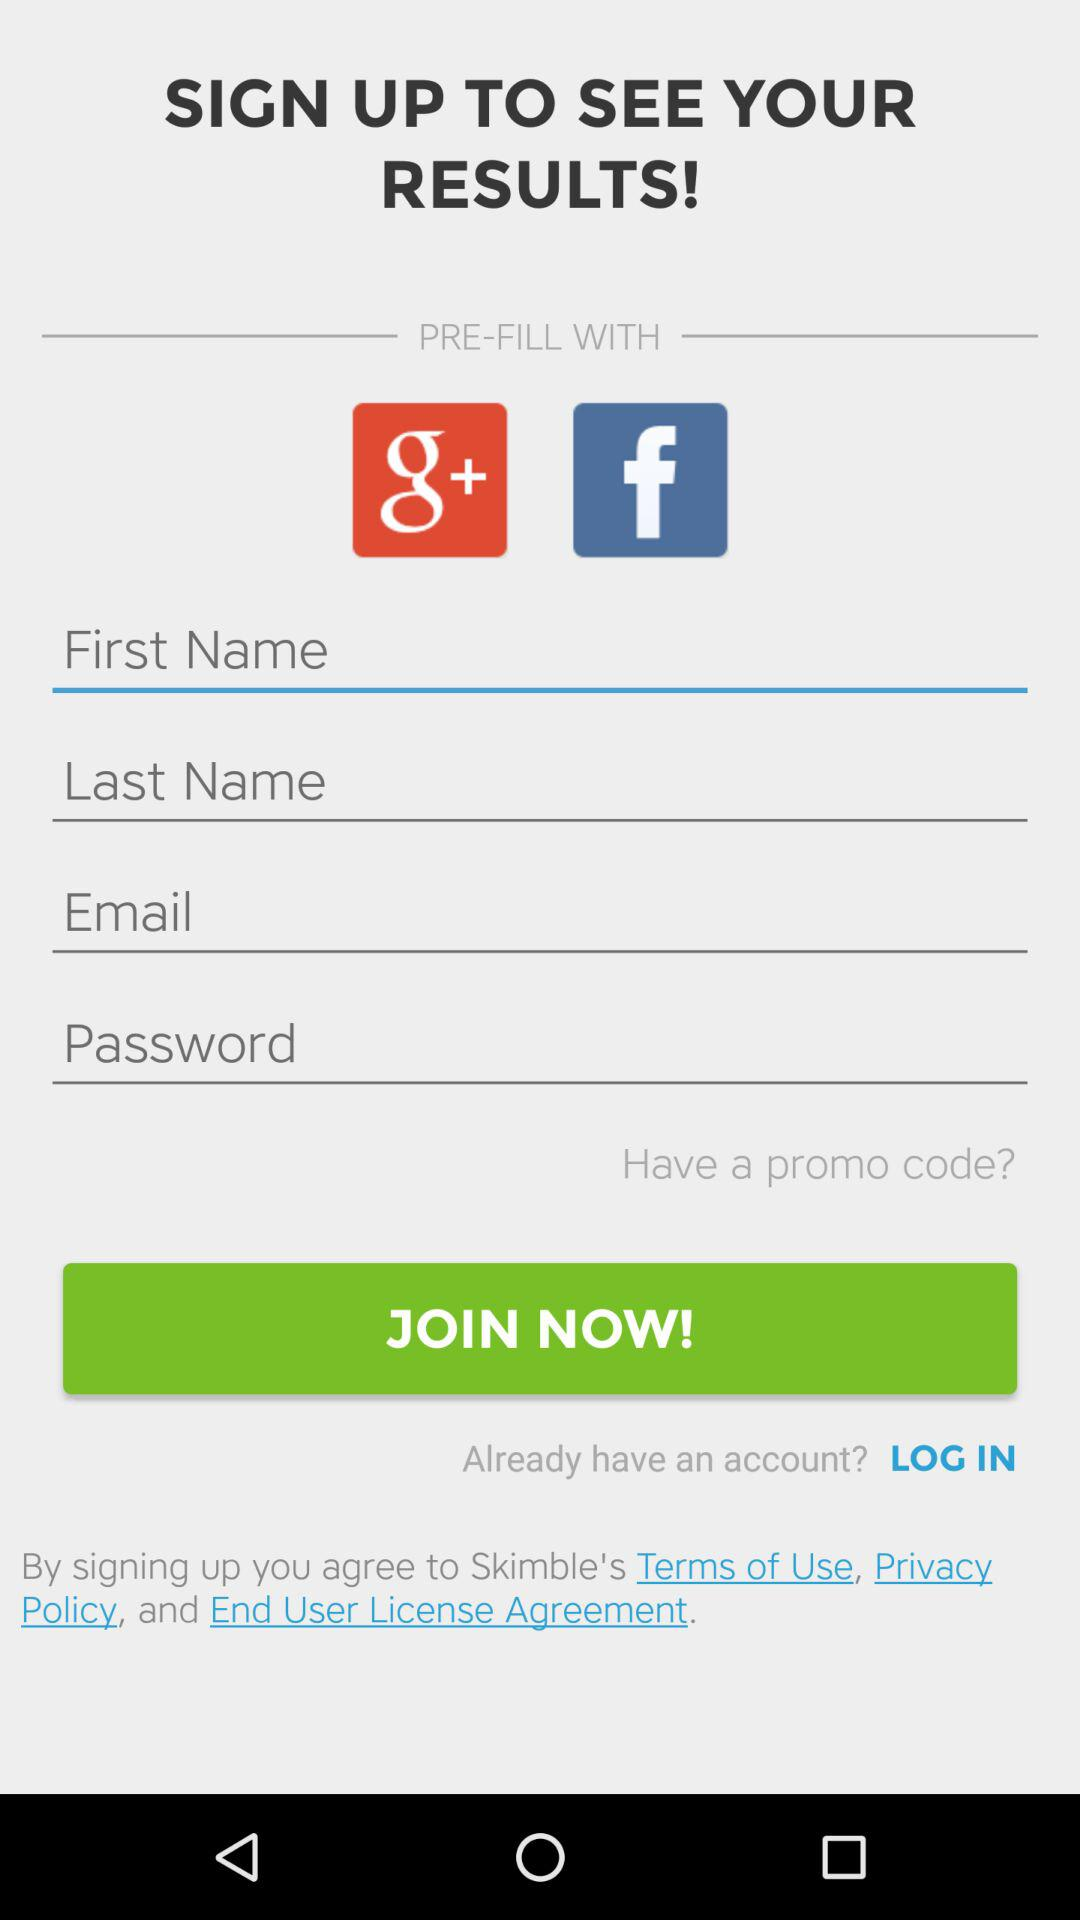Which applications can be used for sign up? The applications are "Google+" and "Facebook". 